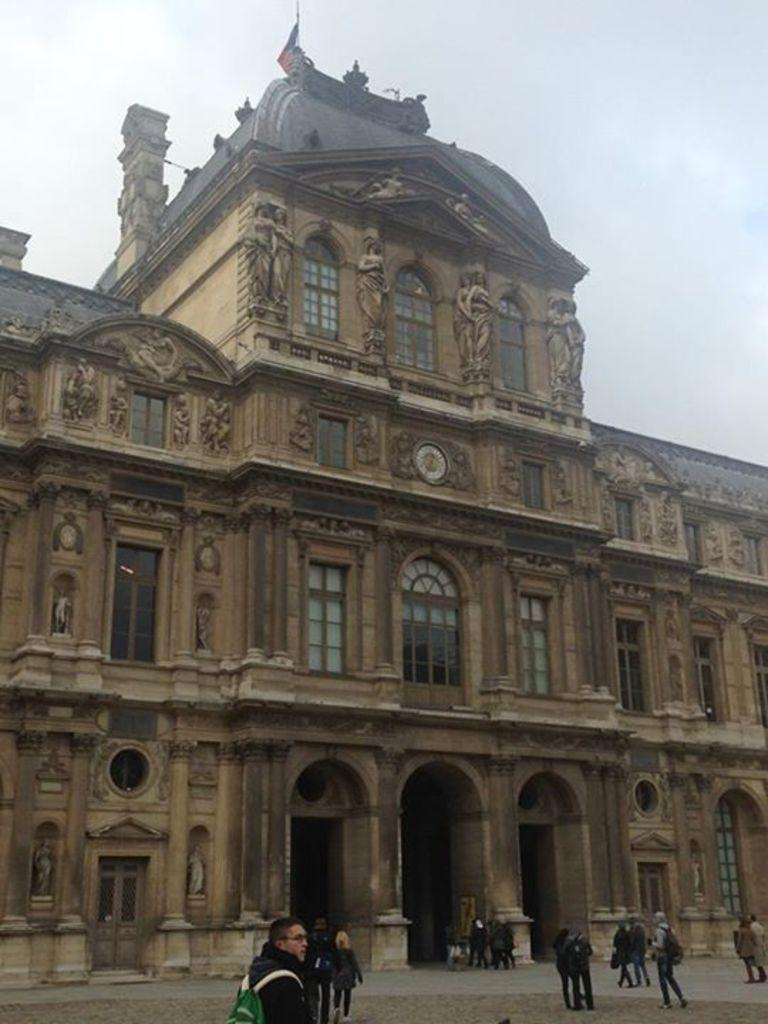What are the people in the image doing? The people in the image are standing on the floor. What structure can be seen in the image? There is a building in the image. What feature of the building is mentioned in the facts? The building has windows. What is visible at the top of the image? The sky is visible at the top of the image. How would you describe the weather based on the sky in the image? The sky is cloudy in the image. How many dimes can be seen on the windows of the building in the image? There are no dimes visible on the windows of the building in the image. What type of wing is attached to the people standing on the floor in the image? There are no wings attached to the people standing on the floor in the image. 